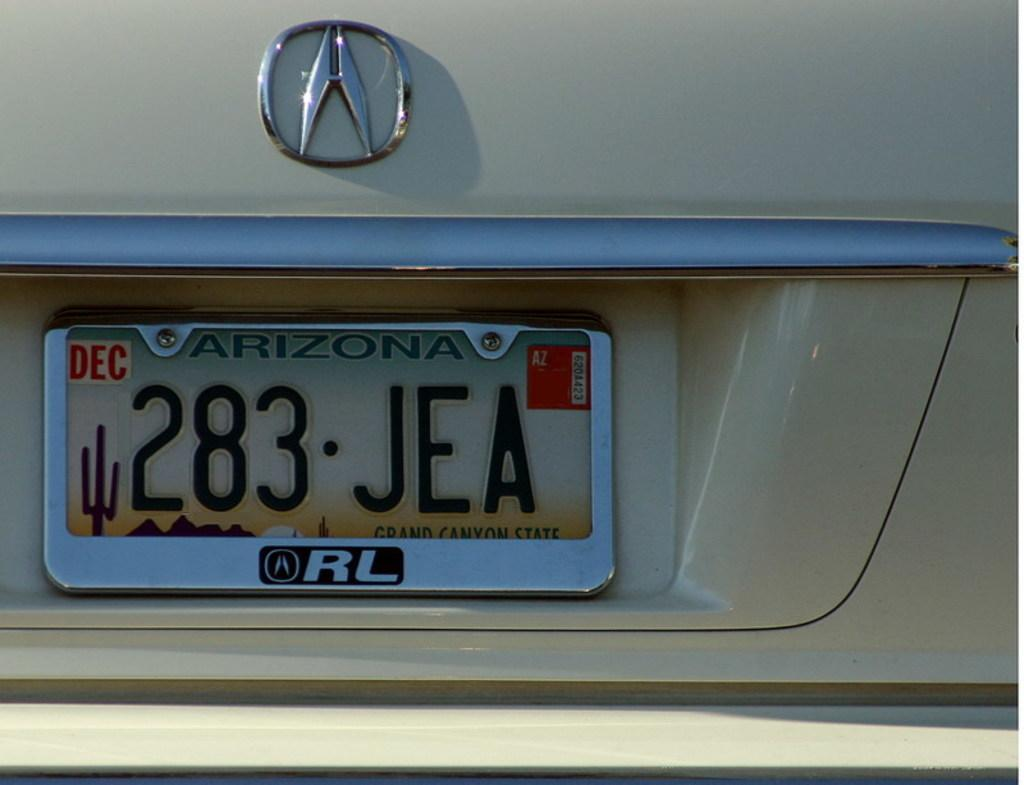What can be seen in the image related to identification or registration? There is a number plate in the image. What else is present in the image related to a vehicle? There is a logo of a vehicle in the image. What type of clouds can be seen in the image? There are no clouds present in the image; it only features a number plate and a vehicle logo. Who is the writer of the logo in the image? The image does not provide information about the logo's designer or writer. 